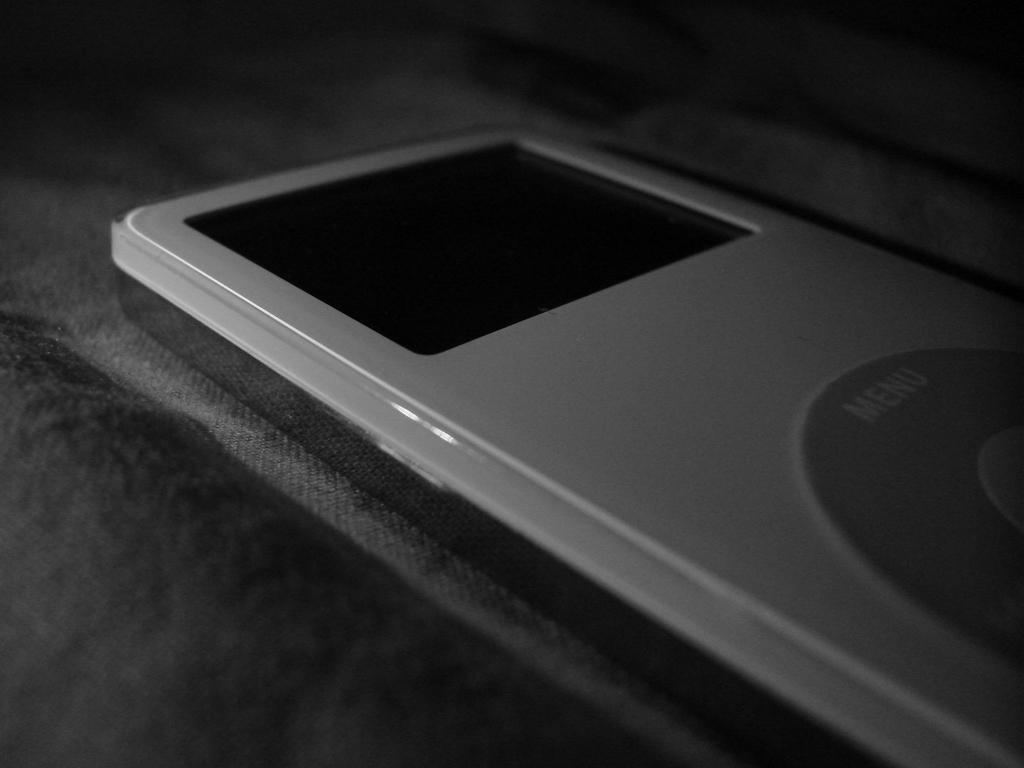Please provide a concise description of this image. This is a black and white picture, in this image we can see an ipod and the background is dark. 